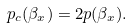Convert formula to latex. <formula><loc_0><loc_0><loc_500><loc_500>p _ { c } ( \beta _ { x } ) = 2 p ( \beta _ { x } ) .</formula> 